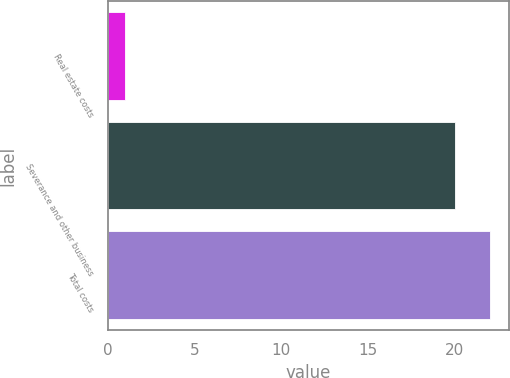<chart> <loc_0><loc_0><loc_500><loc_500><bar_chart><fcel>Real estate costs<fcel>Severance and other business<fcel>Total costs<nl><fcel>1<fcel>20<fcel>22<nl></chart> 